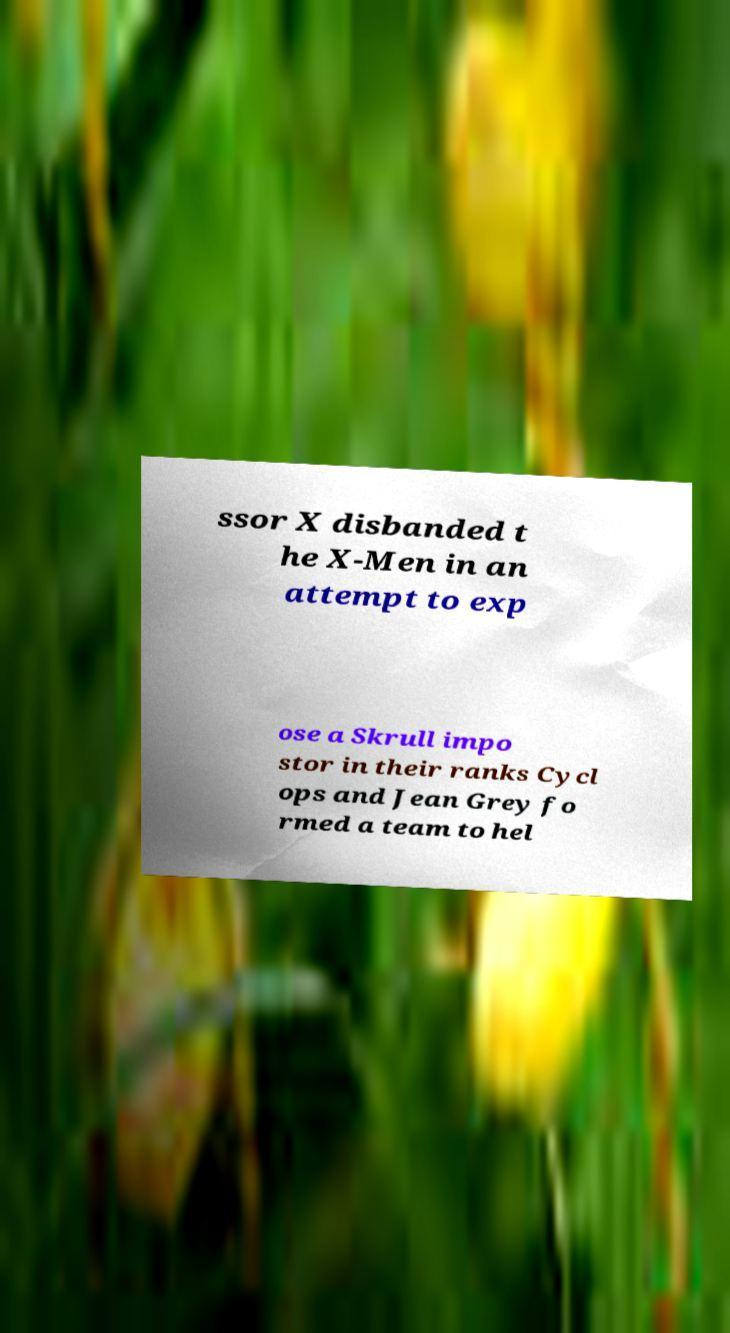Can you accurately transcribe the text from the provided image for me? ssor X disbanded t he X-Men in an attempt to exp ose a Skrull impo stor in their ranks Cycl ops and Jean Grey fo rmed a team to hel 